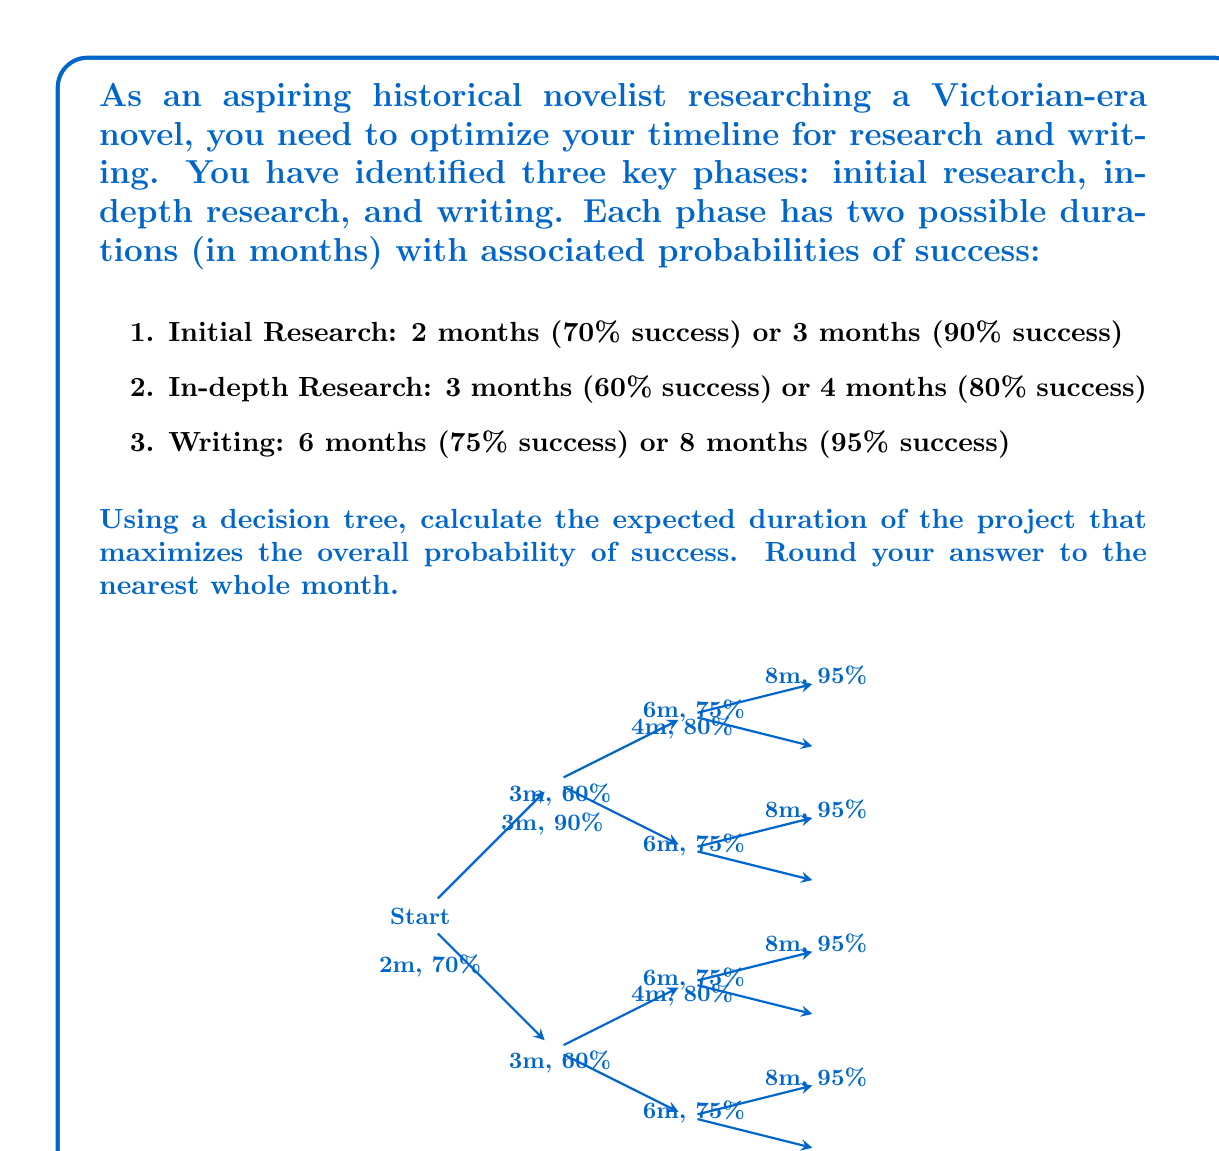Teach me how to tackle this problem. Let's solve this problem step-by-step using a decision tree approach:

1) First, we need to calculate the probability of success for each path in the decision tree:

   Path 1: 2m + 3m + 6m = 11m, P = 0.70 * 0.60 * 0.75 = 0.3150
   Path 2: 2m + 3m + 8m = 13m, P = 0.70 * 0.60 * 0.95 = 0.3990
   Path 3: 2m + 4m + 6m = 12m, P = 0.70 * 0.80 * 0.75 = 0.4200
   Path 4: 2m + 4m + 8m = 14m, P = 0.70 * 0.80 * 0.95 = 0.5320
   Path 5: 3m + 3m + 6m = 12m, P = 0.90 * 0.60 * 0.75 = 0.4050
   Path 6: 3m + 3m + 8m = 14m, P = 0.90 * 0.60 * 0.95 = 0.5130
   Path 7: 3m + 4m + 6m = 13m, P = 0.90 * 0.80 * 0.75 = 0.5400
   Path 8: 3m + 4m + 8m = 15m, P = 0.90 * 0.80 * 0.95 = 0.6840

2) The path with the highest probability of success is Path 8, with a probability of 0.6840 and a duration of 15 months.

3) To calculate the expected duration, we need to consider all paths:

   E(Duration) = 11 * 0.3150 + 13 * 0.3990 + 12 * 0.4200 + 14 * 0.5320 +
                 12 * 0.4050 + 14 * 0.5130 + 13 * 0.5400 + 15 * 0.6840

4) Let's calculate this:

   E(Duration) = 3.465 + 5.187 + 5.040 + 7.448 + 4.860 + 7.182 + 7.020 + 10.260
               = 50.462 months

5) Rounding to the nearest whole month:

   E(Duration) ≈ 50 months

Therefore, the expected duration of the project that maximizes the overall probability of success is approximately 50 months.
Answer: 50 months 